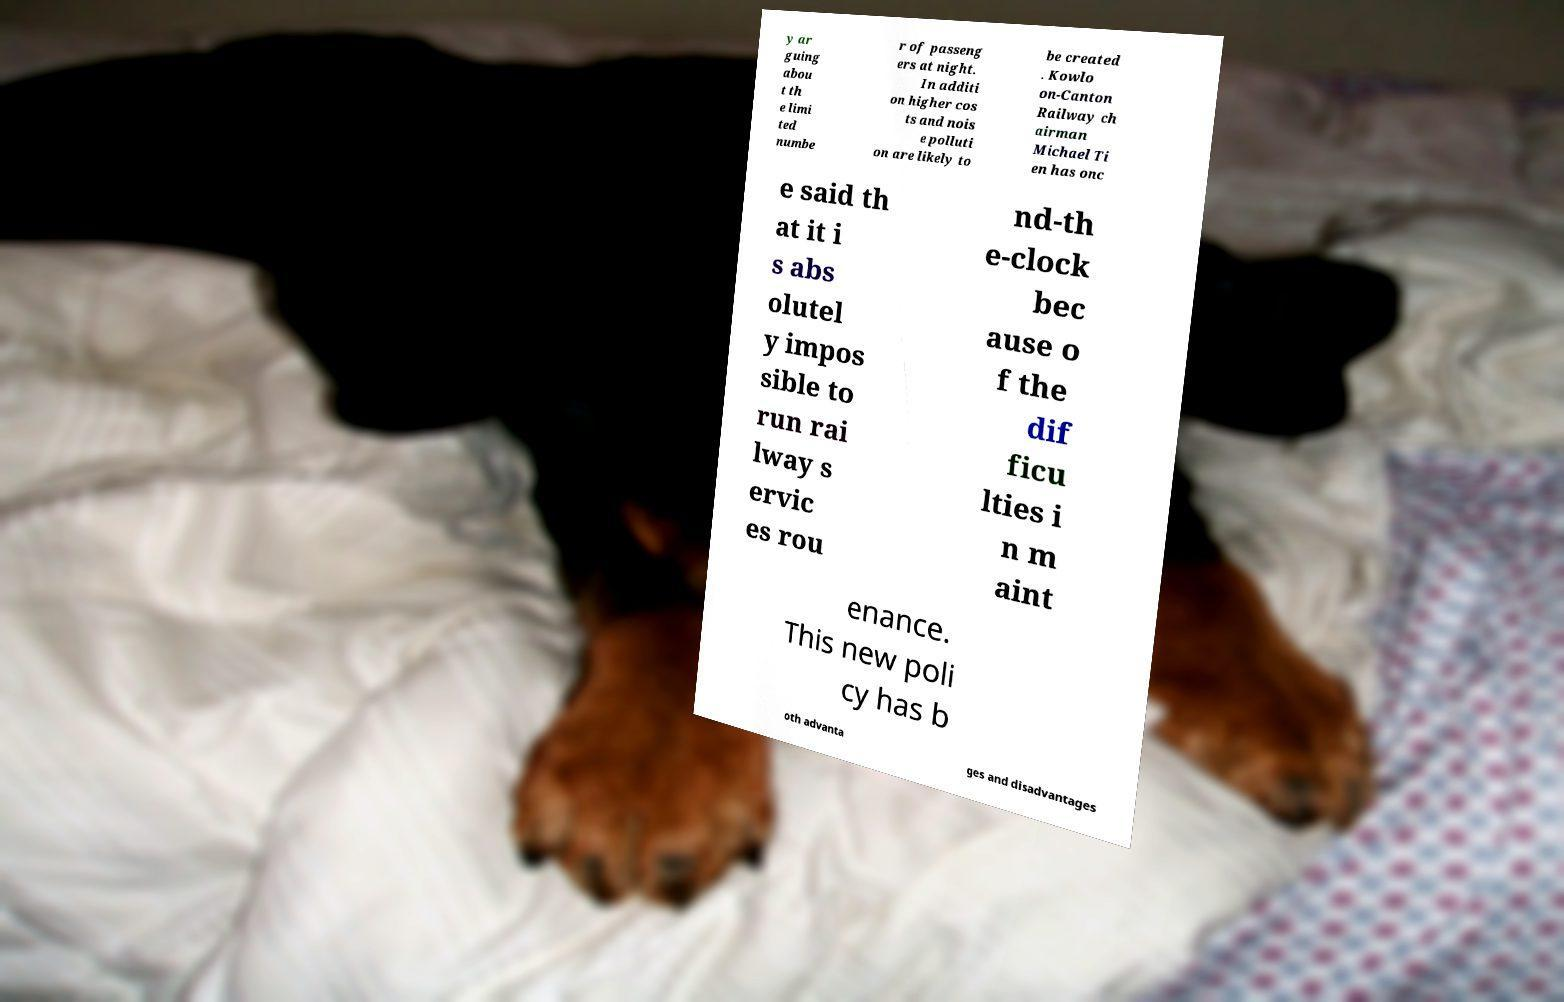Could you extract and type out the text from this image? y ar guing abou t th e limi ted numbe r of passeng ers at night. In additi on higher cos ts and nois e polluti on are likely to be created . Kowlo on-Canton Railway ch airman Michael Ti en has onc e said th at it i s abs olutel y impos sible to run rai lway s ervic es rou nd-th e-clock bec ause o f the dif ficu lties i n m aint enance. This new poli cy has b oth advanta ges and disadvantages 